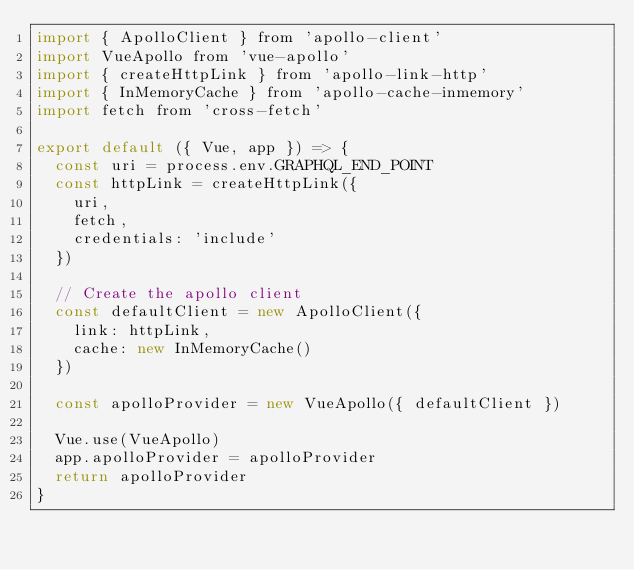Convert code to text. <code><loc_0><loc_0><loc_500><loc_500><_JavaScript_>import { ApolloClient } from 'apollo-client'
import VueApollo from 'vue-apollo'
import { createHttpLink } from 'apollo-link-http'
import { InMemoryCache } from 'apollo-cache-inmemory'
import fetch from 'cross-fetch'

export default ({ Vue, app }) => {
  const uri = process.env.GRAPHQL_END_POINT
  const httpLink = createHttpLink({
    uri,
    fetch,
    credentials: 'include'
  })

  // Create the apollo client
  const defaultClient = new ApolloClient({
    link: httpLink,
    cache: new InMemoryCache()
  })

  const apolloProvider = new VueApollo({ defaultClient })

  Vue.use(VueApollo)
  app.apolloProvider = apolloProvider
  return apolloProvider
}
</code> 